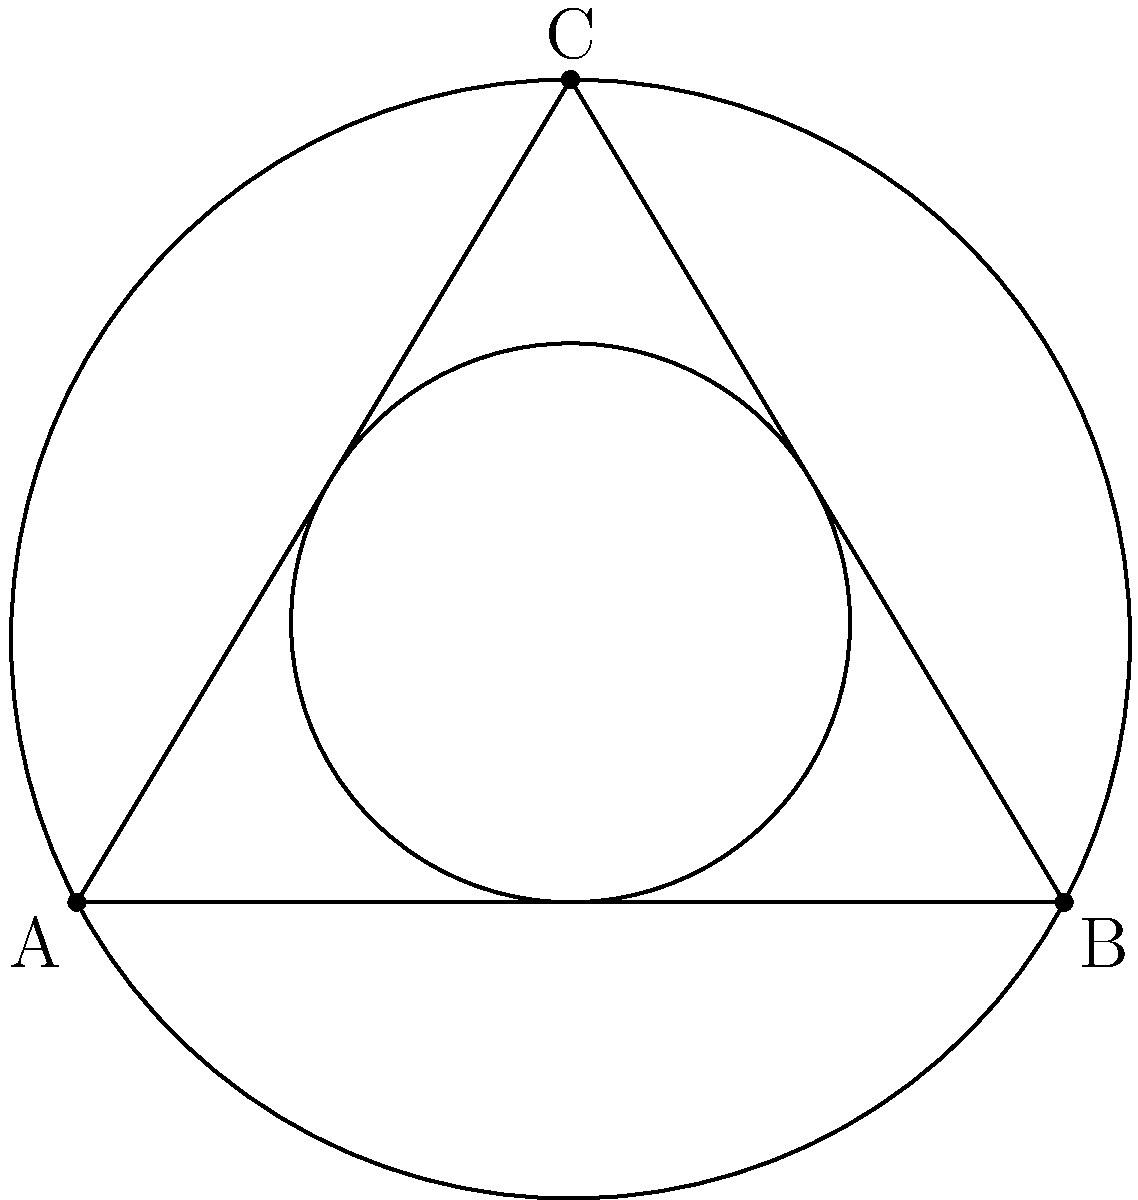In the diagram, a triangle ABC is shown with its inscribed circle (radius $r$) and circumscribed circle (radius $R$). If the area of the triangle is 15 square units and its perimeter is 12 units, determine the ratio of $R$ to $r$. Let's approach this step-by-step:

1) For any triangle, the area $A$ is related to the inradius $r$ and semiperimeter $s$ by:
   $$A = rs$$

2) The semiperimeter $s$ is half the perimeter, so $s = 12/2 = 6$ units.

3) Given the area $A = 15$ and $s = 6$, we can find $r$:
   $$15 = 6r$$
   $$r = 2.5$$ units

4) For any triangle, the area $A$ is also related to the circumradius $R$ by:
   $$A = \frac{abc}{4R}$$
   where $a$, $b$, and $c$ are the side lengths.

5) The product of the side lengths $abc$ is equal to $4Rs$, so:
   $$15 = \frac{4Rs}{4R} = s = 6$$

6) Therefore, $R = 4$ units.

7) The ratio $R:r$ is thus $4 : 2.5$, which simplifies to $8:5$.
Answer: $8:5$ 